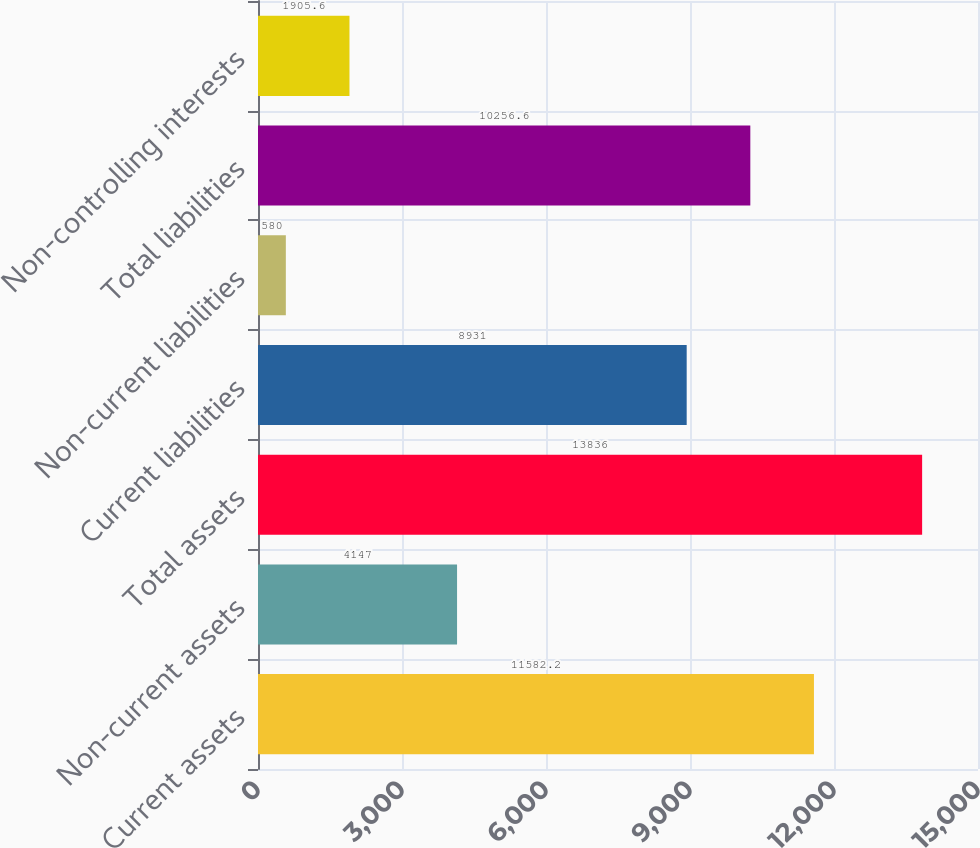Convert chart to OTSL. <chart><loc_0><loc_0><loc_500><loc_500><bar_chart><fcel>Current assets<fcel>Non-current assets<fcel>Total assets<fcel>Current liabilities<fcel>Non-current liabilities<fcel>Total liabilities<fcel>Non-controlling interests<nl><fcel>11582.2<fcel>4147<fcel>13836<fcel>8931<fcel>580<fcel>10256.6<fcel>1905.6<nl></chart> 